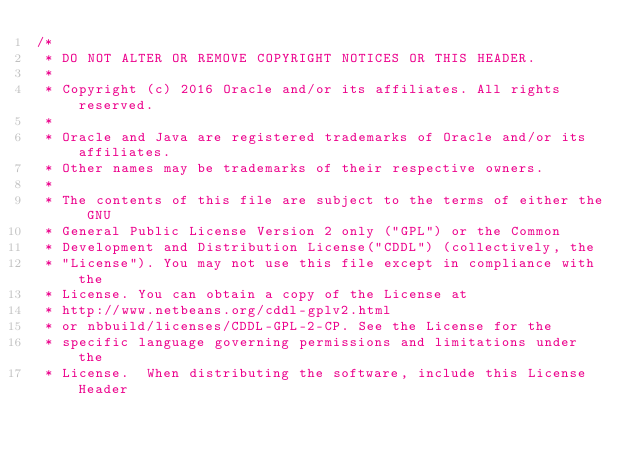<code> <loc_0><loc_0><loc_500><loc_500><_Java_>/*
 * DO NOT ALTER OR REMOVE COPYRIGHT NOTICES OR THIS HEADER.
 *
 * Copyright (c) 2016 Oracle and/or its affiliates. All rights reserved.
 *
 * Oracle and Java are registered trademarks of Oracle and/or its affiliates.
 * Other names may be trademarks of their respective owners.
 *
 * The contents of this file are subject to the terms of either the GNU
 * General Public License Version 2 only ("GPL") or the Common
 * Development and Distribution License("CDDL") (collectively, the
 * "License"). You may not use this file except in compliance with the
 * License. You can obtain a copy of the License at
 * http://www.netbeans.org/cddl-gplv2.html
 * or nbbuild/licenses/CDDL-GPL-2-CP. See the License for the
 * specific language governing permissions and limitations under the
 * License.  When distributing the software, include this License Header</code> 